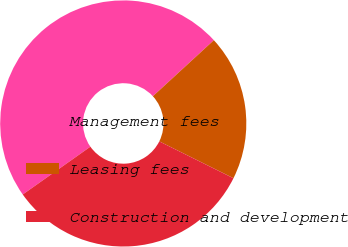Convert chart. <chart><loc_0><loc_0><loc_500><loc_500><pie_chart><fcel>Management fees<fcel>Leasing fees<fcel>Construction and development<nl><fcel>47.96%<fcel>19.17%<fcel>32.87%<nl></chart> 